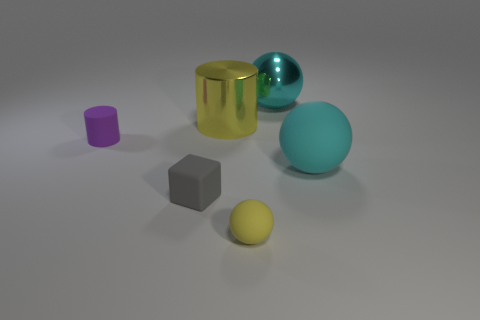Are there any other things that have the same size as the cube?
Offer a terse response. Yes. Are there any cyan shiny balls?
Your response must be concise. Yes. What size is the cylinder that is the same color as the tiny matte sphere?
Your response must be concise. Large. How big is the rubber ball that is to the left of the big cyan sphere in front of the metal object on the right side of the yellow rubber sphere?
Make the answer very short. Small. What number of tiny yellow spheres are made of the same material as the yellow cylinder?
Your answer should be compact. 0. What number of brown metal balls have the same size as the yellow metallic object?
Your response must be concise. 0. What is the gray cube that is in front of the large ball that is right of the cyan metallic object behind the tiny yellow rubber sphere made of?
Keep it short and to the point. Rubber. What number of things are cubes or big green matte things?
Give a very brief answer. 1. Is there anything else that has the same material as the yellow cylinder?
Keep it short and to the point. Yes. The cyan metal object is what shape?
Provide a succinct answer. Sphere. 